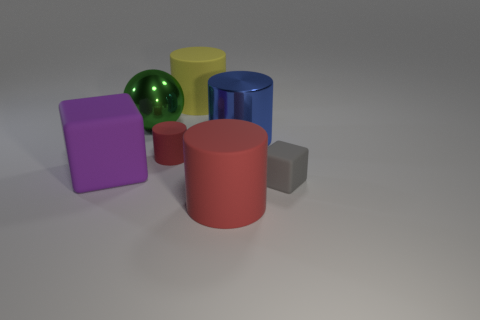Subtract 1 cylinders. How many cylinders are left? 3 Add 2 large blue shiny cylinders. How many objects exist? 9 Subtract all cylinders. How many objects are left? 3 Subtract 0 brown balls. How many objects are left? 7 Subtract all gray blocks. Subtract all purple matte cubes. How many objects are left? 5 Add 7 gray rubber blocks. How many gray rubber blocks are left? 8 Add 7 tiny red things. How many tiny red things exist? 8 